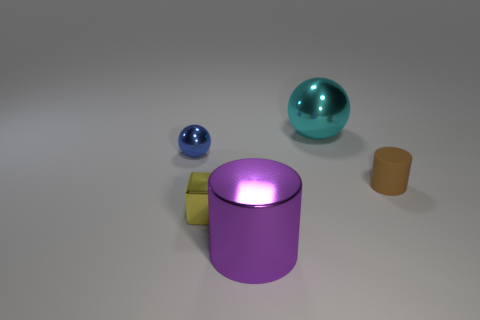Add 1 large cyan cylinders. How many objects exist? 6 Subtract all blocks. How many objects are left? 4 Subtract all gray cubes. How many gray balls are left? 0 Subtract all large green rubber cylinders. Subtract all large shiny balls. How many objects are left? 4 Add 2 big metallic balls. How many big metallic balls are left? 3 Add 5 tiny yellow shiny things. How many tiny yellow shiny things exist? 6 Subtract all brown cylinders. How many cylinders are left? 1 Subtract 0 blue cylinders. How many objects are left? 5 Subtract 2 cylinders. How many cylinders are left? 0 Subtract all blue spheres. Subtract all yellow cubes. How many spheres are left? 1 